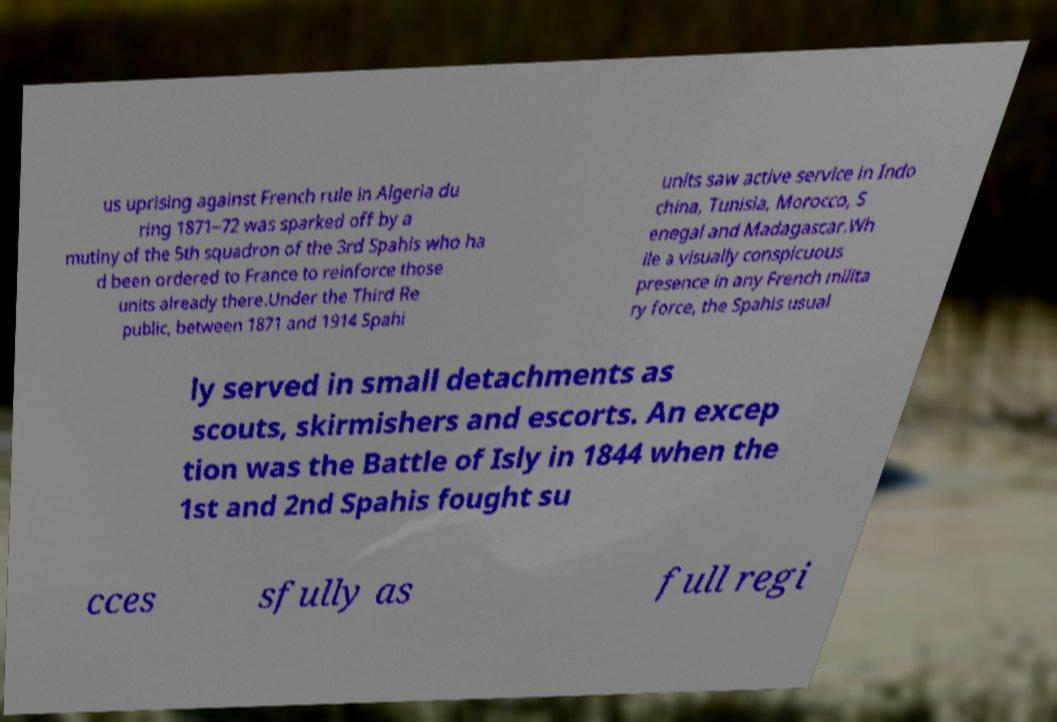Could you assist in decoding the text presented in this image and type it out clearly? us uprising against French rule in Algeria du ring 1871–72 was sparked off by a mutiny of the 5th squadron of the 3rd Spahis who ha d been ordered to France to reinforce those units already there.Under the Third Re public, between 1871 and 1914 Spahi units saw active service in Indo china, Tunisia, Morocco, S enegal and Madagascar.Wh ile a visually conspicuous presence in any French milita ry force, the Spahis usual ly served in small detachments as scouts, skirmishers and escorts. An excep tion was the Battle of Isly in 1844 when the 1st and 2nd Spahis fought su cces sfully as full regi 